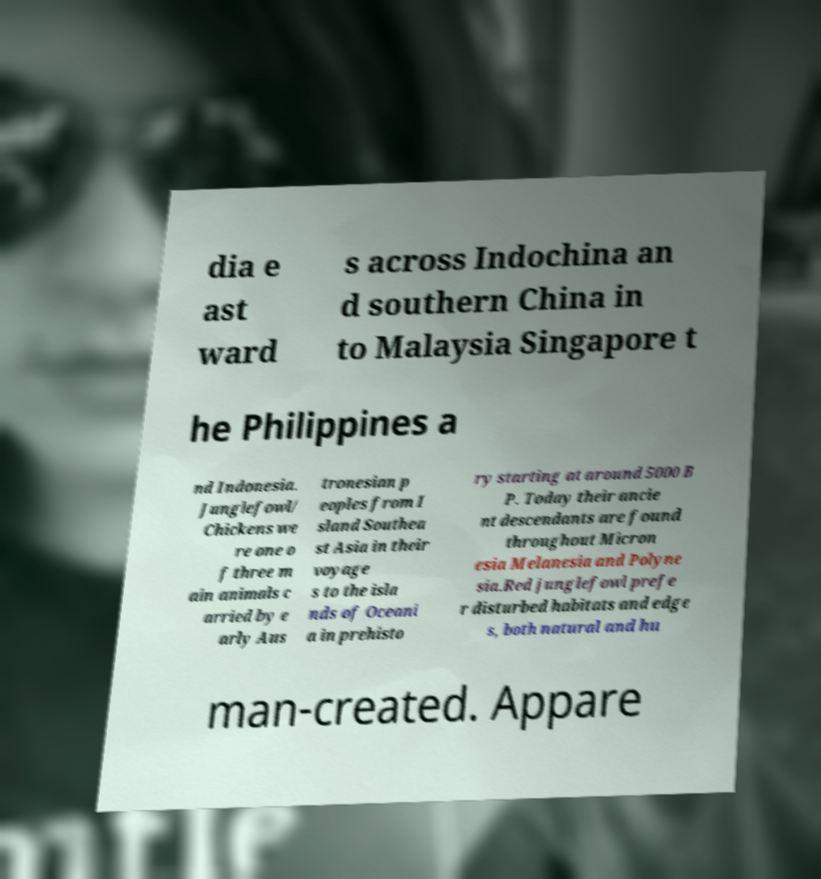Can you read and provide the text displayed in the image?This photo seems to have some interesting text. Can you extract and type it out for me? dia e ast ward s across Indochina an d southern China in to Malaysia Singapore t he Philippines a nd Indonesia. Junglefowl/ Chickens we re one o f three m ain animals c arried by e arly Aus tronesian p eoples from I sland Southea st Asia in their voyage s to the isla nds of Oceani a in prehisto ry starting at around 5000 B P. Today their ancie nt descendants are found throughout Micron esia Melanesia and Polyne sia.Red junglefowl prefe r disturbed habitats and edge s, both natural and hu man-created. Appare 